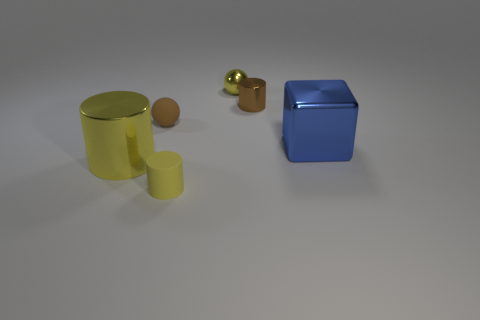Are there any other things that have the same shape as the blue shiny object?
Ensure brevity in your answer.  No. What number of rubber cylinders have the same size as the blue metal thing?
Ensure brevity in your answer.  0. Is the size of the yellow shiny object in front of the shiny block the same as the large blue metal cube?
Keep it short and to the point. Yes. What is the shape of the blue thing?
Make the answer very short. Cube. There is a ball that is the same color as the small matte cylinder; what is its size?
Keep it short and to the point. Small. Do the yellow cylinder that is behind the small yellow cylinder and the brown cylinder have the same material?
Ensure brevity in your answer.  Yes. Are there any metal cylinders of the same color as the matte ball?
Offer a very short reply. Yes. There is a big object that is to the left of the blue metallic thing; is its shape the same as the brown thing to the left of the yellow rubber object?
Your answer should be compact. No. Are there any small brown things that have the same material as the yellow sphere?
Keep it short and to the point. Yes. What number of brown things are either tiny cylinders or rubber spheres?
Provide a succinct answer. 2. 